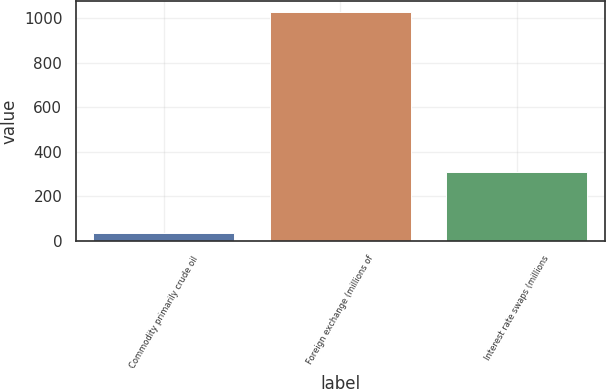<chart> <loc_0><loc_0><loc_500><loc_500><bar_chart><fcel>Commodity primarily crude oil<fcel>Foreign exchange (millions of<fcel>Interest rate swaps (millions<nl><fcel>35<fcel>1025<fcel>310<nl></chart> 